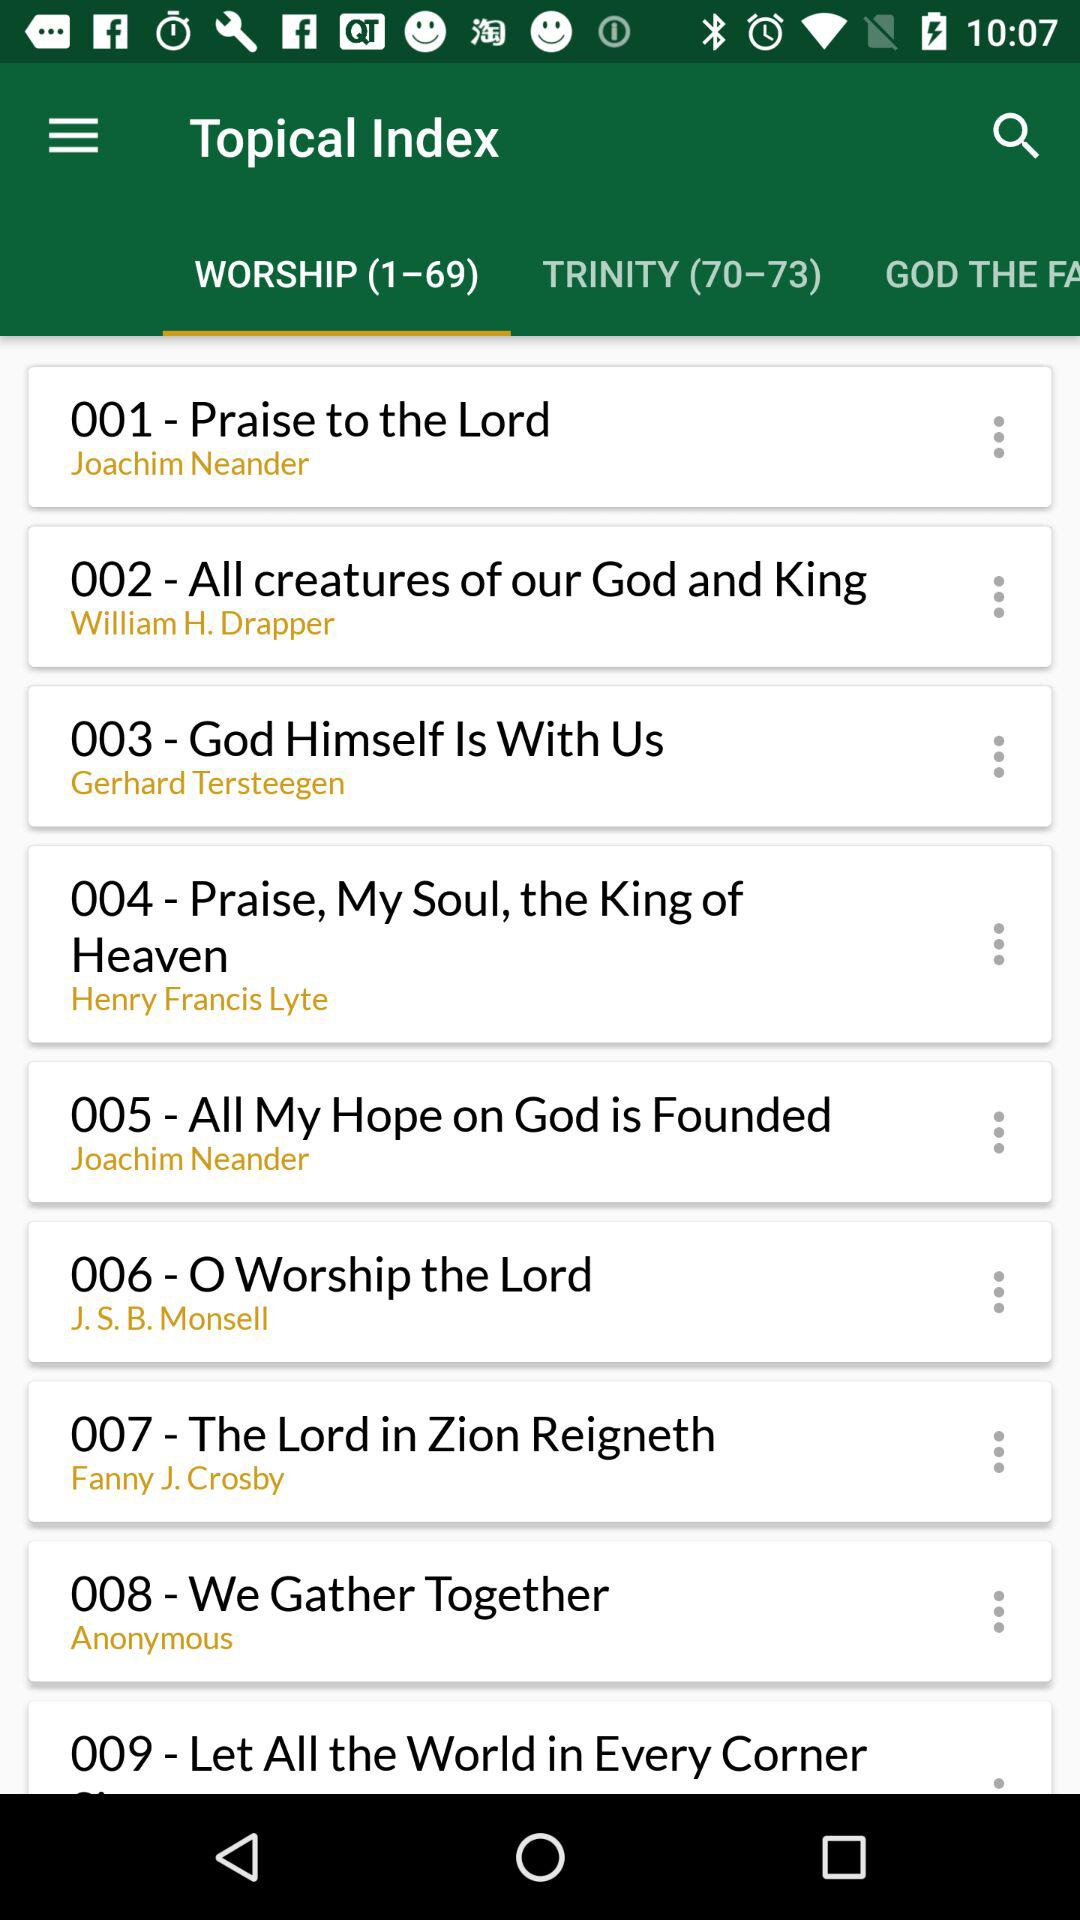Who wrote the hymn "God Himself Is With Us"? The hymn "God Himself Is With Us" was written by Gerhard Tersteegen. 